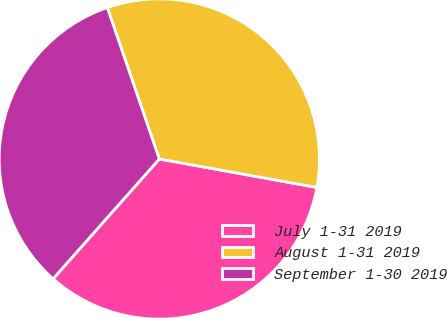<chart> <loc_0><loc_0><loc_500><loc_500><pie_chart><fcel>July 1-31 2019<fcel>August 1-31 2019<fcel>September 1-30 2019<nl><fcel>33.7%<fcel>33.11%<fcel>33.19%<nl></chart> 